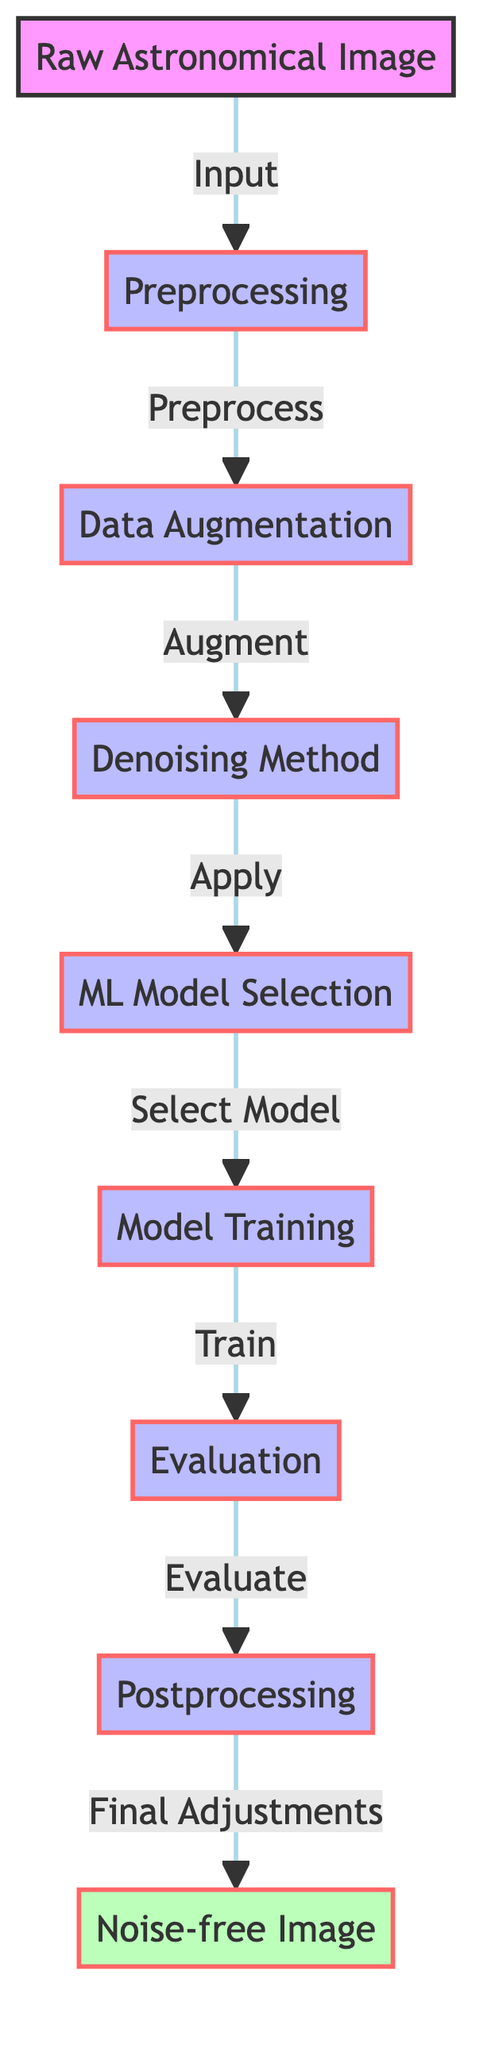What is the first step in the diagram? The first step in the diagram is the "Raw Astronomical Image," which is the starting point for the process.
Answer: Raw Astronomical Image How many processes are involved in the diagram? There are six processes indicated in the diagram: Preprocessing, Data Augmentation, Denoising Method, ML Model Selection, Training, and Postprocessing.
Answer: Six What is the output of the diagram? The output of the diagram is the "Noise-free Image," which represents the final result after all processing steps.
Answer: Noise-free Image Which node comes after the Data Augmentation node? The node that comes after the Data Augmentation node in the flow is the Denoising Method, indicating it follows directly in the processing sequence.
Answer: Denoising Method How does the model evaluation relate to the training? The model evaluation directly follows the training step, indicating that evaluation is done to assess the performance of the model after it has been trained.
Answer: Evaluates What are the final adjustments made to in the diagram? The final adjustments are made to the outputs, specifically to the "Noise-free Image," suggesting that postprocessing refines the final image.
Answer: Noise-free Image Which step receives the output from the preprocessing? The step that receives the output from the preprocessing step is Data Augmentation, showing that augmentation utilizes preprocessed data.
Answer: Data Augmentation What is the role of the Denoising Method in this process? The Denoising Method's role is to apply suitable techniques to reduce noise from the image, critically impacting the quality of the final output.
Answer: Reduce noise Where does the noise-free image originate in the process? The noise-free image originates from the Postprocessing step, indicating that post-processing is the last phase where the final refinement occurs before reaching the output.
Answer: Postprocessing 